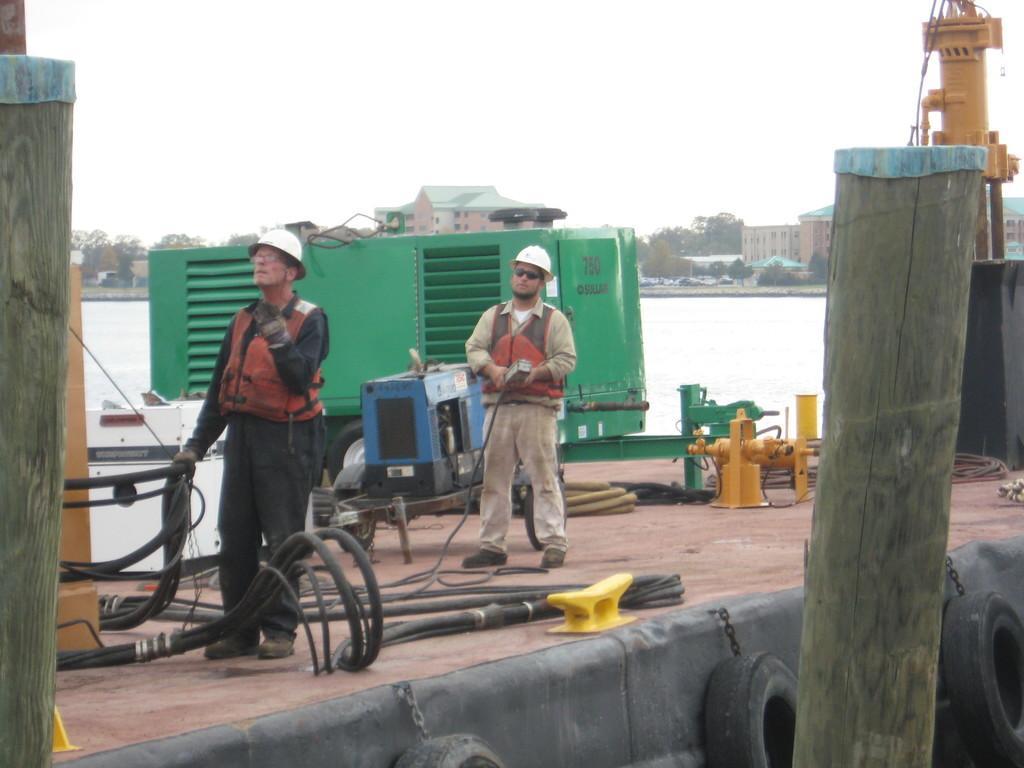Could you give a brief overview of what you see in this image? In this image I can see two person standing. The person in front wearing brown and black color dress and the other person is wearing cream color dress. In front I can see an object which is in green color. Background I can see water, few buildings in brown and cream color, trees in green color and sky is in white color. 